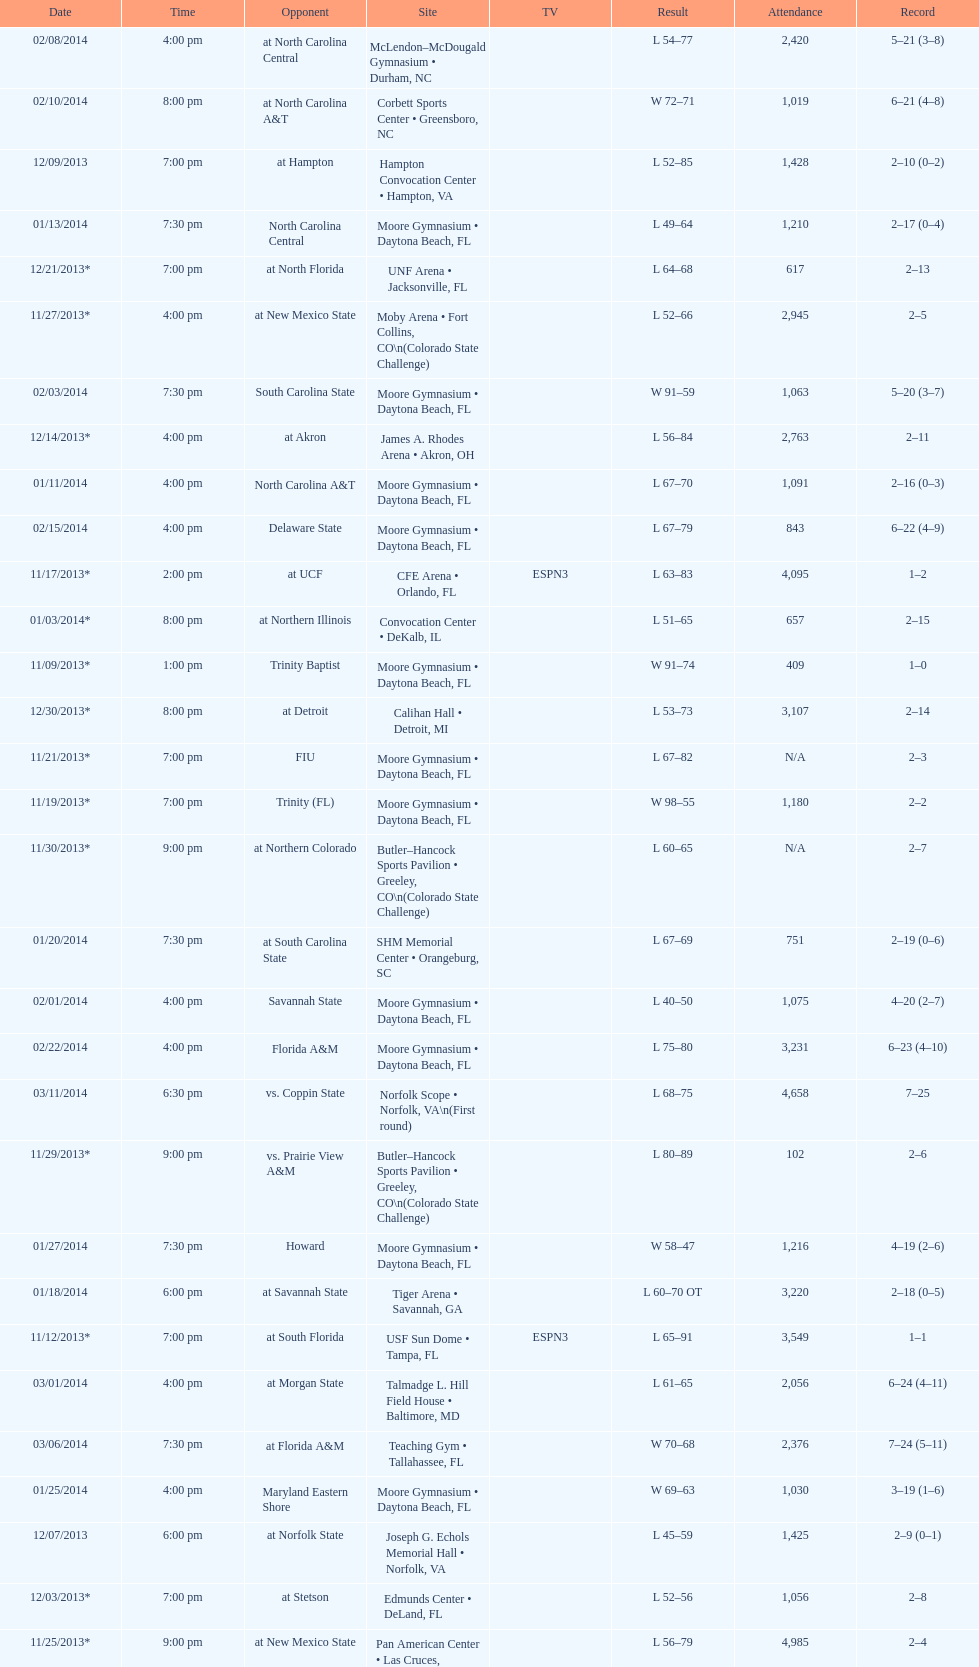How many teams had at most an attendance of 1,000? 6. 